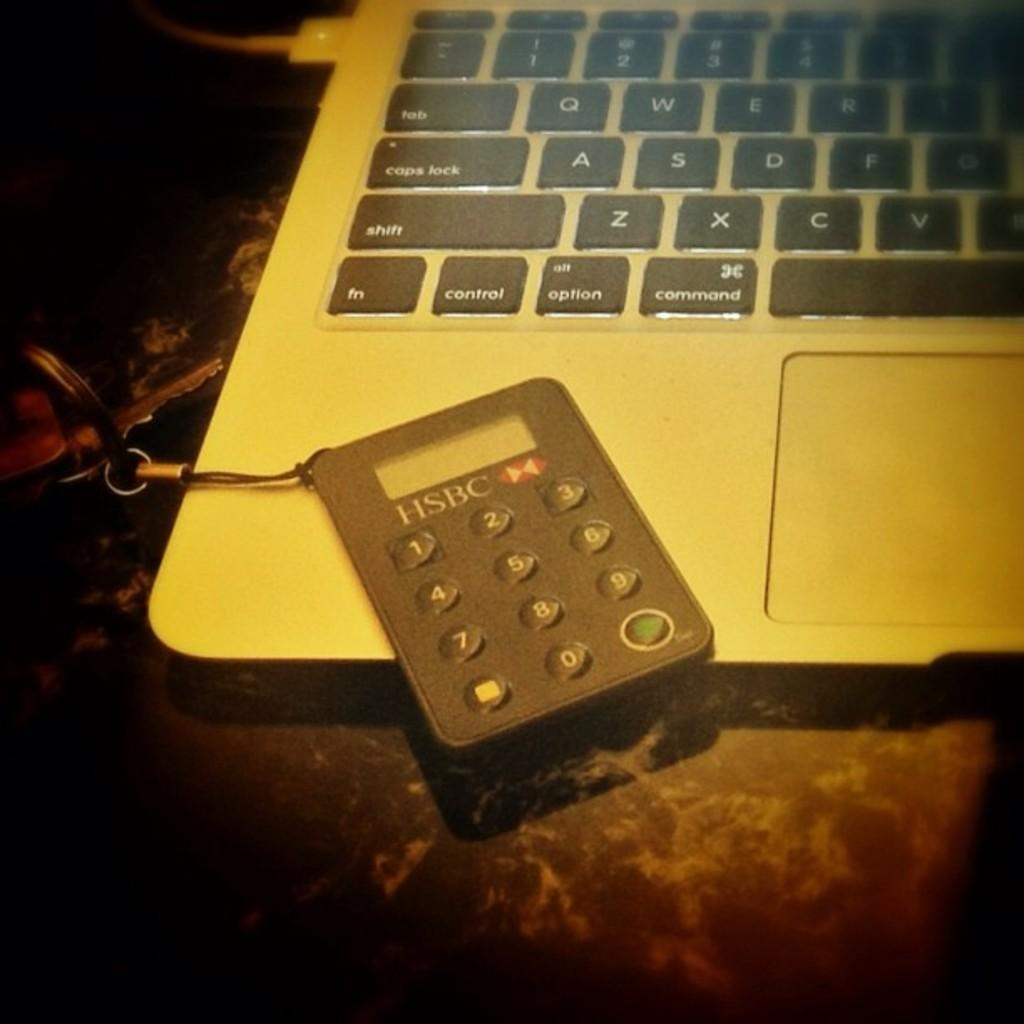What piece of furniture is at the bottom of the image? There is a table at the bottom of the image. What is on top of the table in the image? There is a laptop, keys, and a calculator on the table. What type of electronic device is on the table? There is a laptop on the table. What other objects are on the table? There are keys and a calculator on the table. How does the carriage pull the oil in the image? There is no carriage or oil present in the image. 